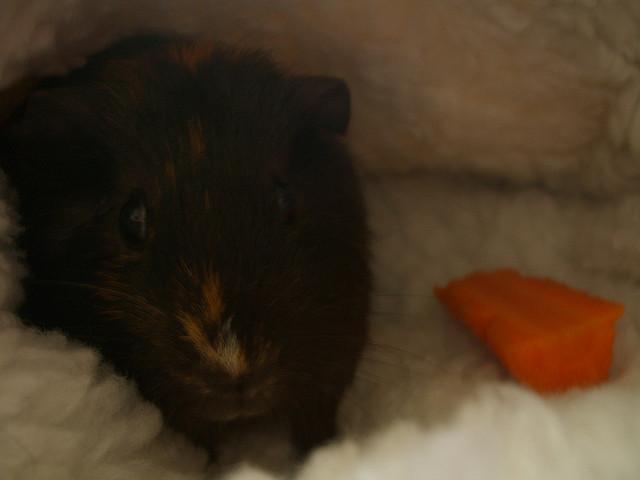How many motorcycles are in the picture?
Give a very brief answer. 0. 